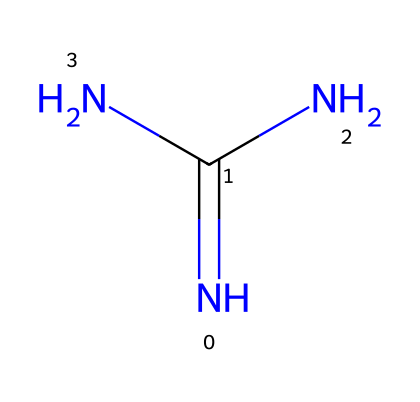How many nitrogen atoms are in this chemical structure? The SMILES representation has two nitrogen atoms depicted in the structure (one in the central position and one as part of the terminal amino group), making the total count of nitrogen atoms present in the molecule equal to three.
Answer: three What type of bonding is prevalent in this molecule? The molecule contains mainly covalent bonds, as evidenced by the sharing of electrons between nitrogen atoms and the carbon atom to form the amidine structure.
Answer: covalent bonds What is the functional group present in this chemical? The chemical consists of an amidine functional group, characterized by the presence of the nitrogen atoms connected to a carbon atom via a double bond and to another nitrogen atom, meeting the criteria for an amidine.
Answer: amidine How does the presence of electron-rich nitrogen influence reactivity? Given that the molecule has electron-rich nitrogen atoms due to the lone pairs available on the nitrogen, this facilitates nucleophilic character, enhancing the ability of the molecule to act as a superbasic structure that can generate reactive species.
Answer: enhances nucleophilicity What structural feature indicates potential hydrogen bonding capabilities? The presence of the amino (-NH2) group in the structure signifies potential for hydrogen bonding due to the available hydrogen atoms that can interact with electronegative atoms like oxygen in other molecules, promoting solubility and interaction with organic compounds.
Answer: amino group What is the molecular hybridization of the central carbon atom? The carbon in this chemical displays sp2 hybridization, indicated by the presence of a double bond with nitrogen and the connection to two additional nitrogen atoms within a planar structure, aligning with the typical geometry seen in amidines.
Answer: sp2 